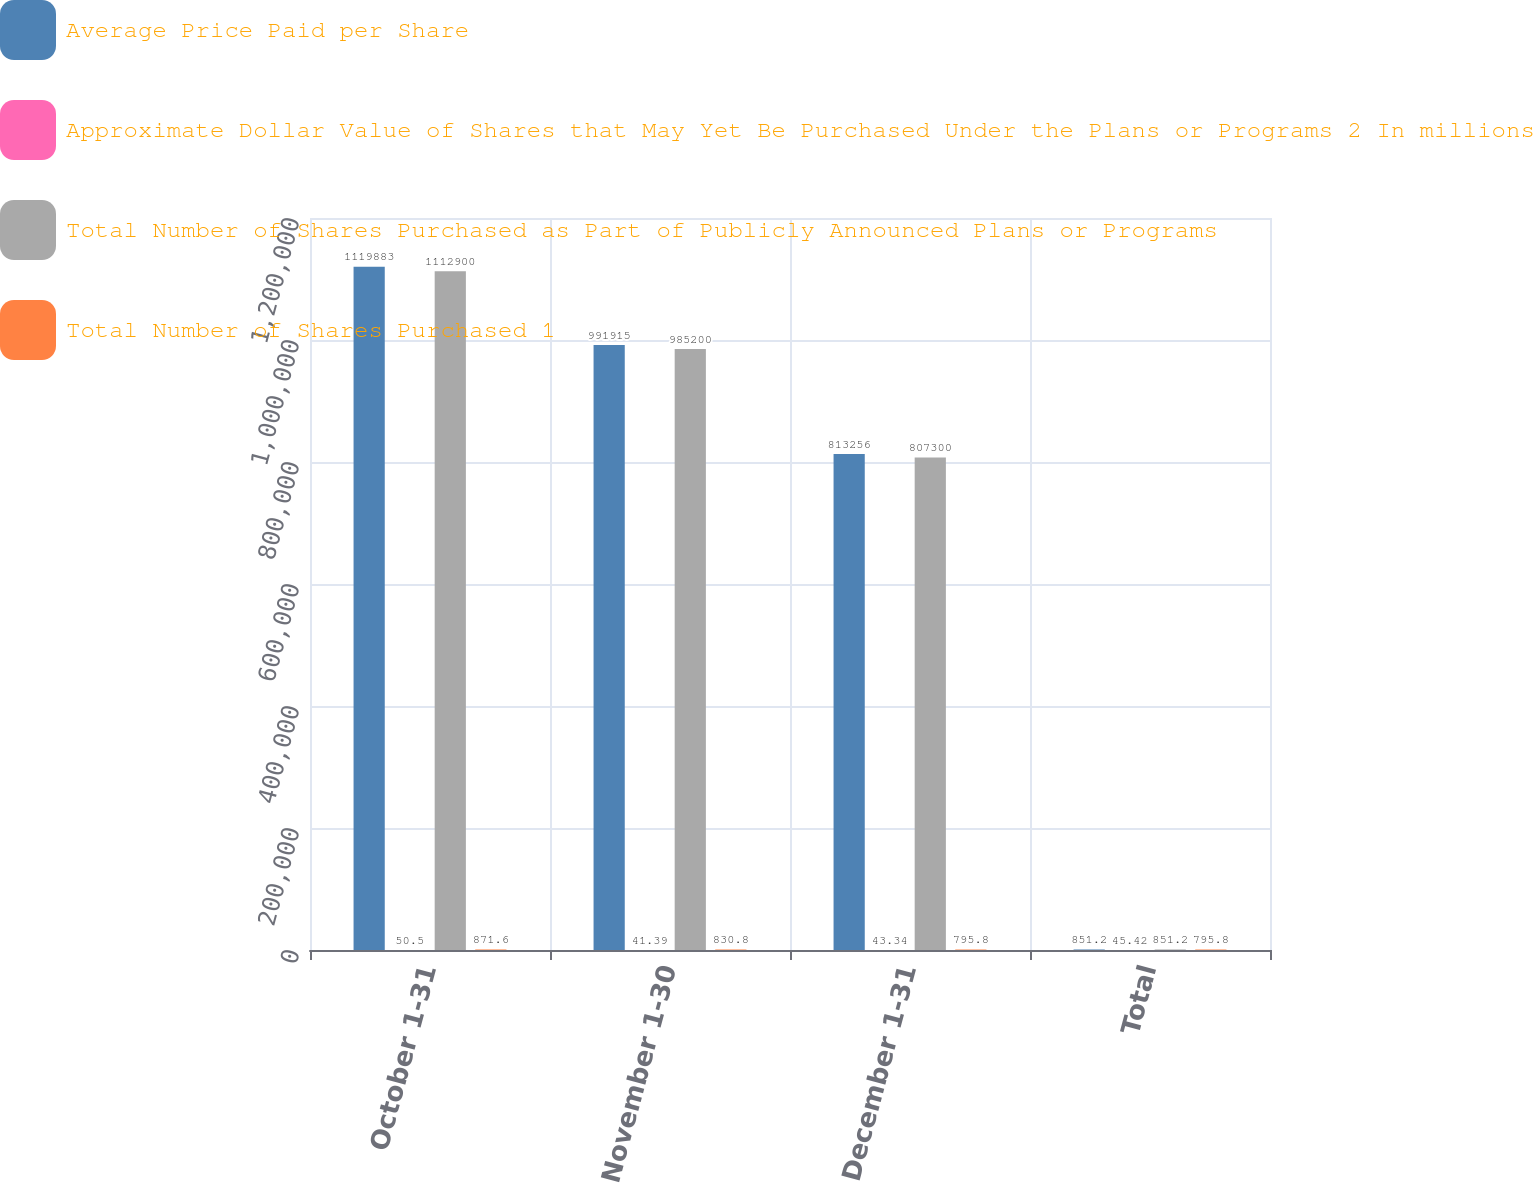<chart> <loc_0><loc_0><loc_500><loc_500><stacked_bar_chart><ecel><fcel>October 1-31<fcel>November 1-30<fcel>December 1-31<fcel>Total<nl><fcel>Average Price Paid per Share<fcel>1.11988e+06<fcel>991915<fcel>813256<fcel>851.2<nl><fcel>Approximate Dollar Value of Shares that May Yet Be Purchased Under the Plans or Programs 2 In millions<fcel>50.5<fcel>41.39<fcel>43.34<fcel>45.42<nl><fcel>Total Number of Shares Purchased as Part of Publicly Announced Plans or Programs<fcel>1.1129e+06<fcel>985200<fcel>807300<fcel>851.2<nl><fcel>Total Number of Shares Purchased 1<fcel>871.6<fcel>830.8<fcel>795.8<fcel>795.8<nl></chart> 